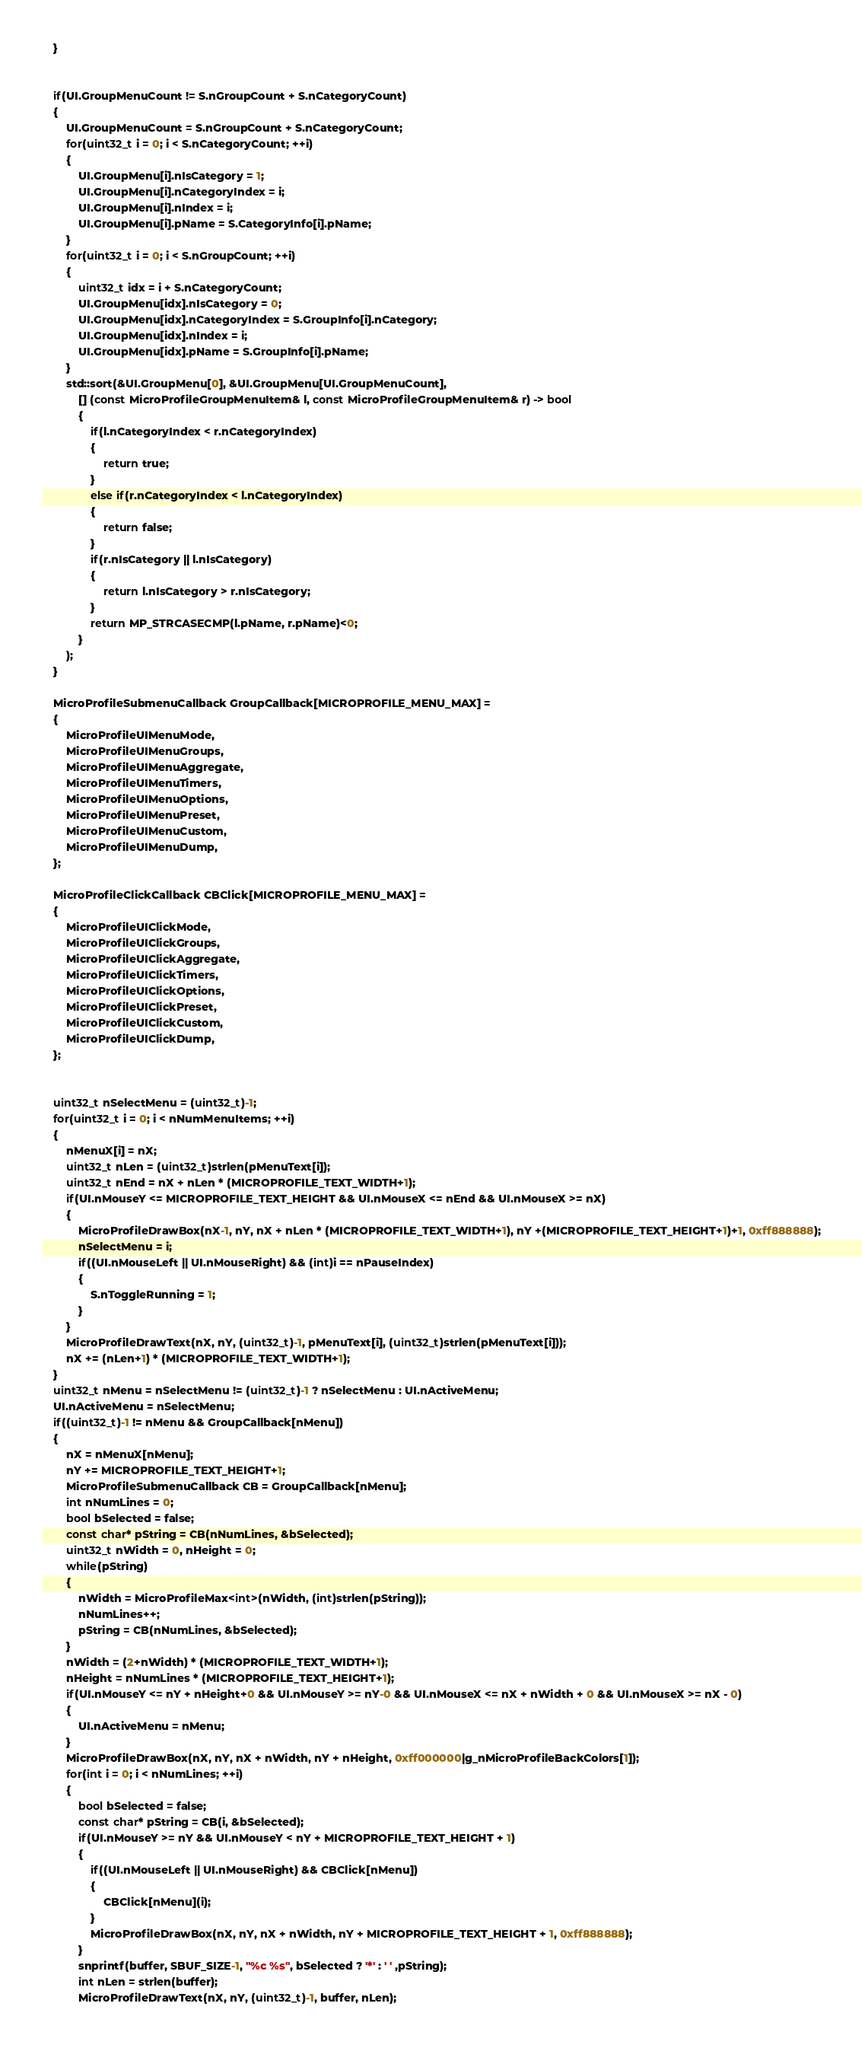Convert code to text. <code><loc_0><loc_0><loc_500><loc_500><_C_>	}


	if(UI.GroupMenuCount != S.nGroupCount + S.nCategoryCount)
	{
		UI.GroupMenuCount = S.nGroupCount + S.nCategoryCount;
		for(uint32_t i = 0; i < S.nCategoryCount; ++i)
		{
			UI.GroupMenu[i].nIsCategory = 1;
			UI.GroupMenu[i].nCategoryIndex = i;
			UI.GroupMenu[i].nIndex = i;
			UI.GroupMenu[i].pName = S.CategoryInfo[i].pName;
		}
		for(uint32_t i = 0; i < S.nGroupCount; ++i)
		{
			uint32_t idx = i + S.nCategoryCount;
			UI.GroupMenu[idx].nIsCategory = 0;
			UI.GroupMenu[idx].nCategoryIndex = S.GroupInfo[i].nCategory;
			UI.GroupMenu[idx].nIndex = i;
			UI.GroupMenu[idx].pName = S.GroupInfo[i].pName;
		}
		std::sort(&UI.GroupMenu[0], &UI.GroupMenu[UI.GroupMenuCount], 
			[] (const MicroProfileGroupMenuItem& l, const MicroProfileGroupMenuItem& r) -> bool
			{
				if(l.nCategoryIndex < r.nCategoryIndex)
				{
					return true;
				}
				else if(r.nCategoryIndex < l.nCategoryIndex)
				{
					return false;
				}
				if(r.nIsCategory || l.nIsCategory)
				{
					return l.nIsCategory > r.nIsCategory;
				}
				return MP_STRCASECMP(l.pName, r.pName)<0;
			}
		);
	}

	MicroProfileSubmenuCallback GroupCallback[MICROPROFILE_MENU_MAX] = 
	{
		MicroProfileUIMenuMode,
		MicroProfileUIMenuGroups,
		MicroProfileUIMenuAggregate,
		MicroProfileUIMenuTimers,
		MicroProfileUIMenuOptions,
		MicroProfileUIMenuPreset,
		MicroProfileUIMenuCustom,
		MicroProfileUIMenuDump,
	};

	MicroProfileClickCallback CBClick[MICROPROFILE_MENU_MAX] =
	{
		MicroProfileUIClickMode,
		MicroProfileUIClickGroups,
		MicroProfileUIClickAggregate,
		MicroProfileUIClickTimers,
		MicroProfileUIClickOptions,
		MicroProfileUIClickPreset,
		MicroProfileUIClickCustom,
		MicroProfileUIClickDump,
	};


	uint32_t nSelectMenu = (uint32_t)-1;
	for(uint32_t i = 0; i < nNumMenuItems; ++i)
	{
		nMenuX[i] = nX;
		uint32_t nLen = (uint32_t)strlen(pMenuText[i]);
		uint32_t nEnd = nX + nLen * (MICROPROFILE_TEXT_WIDTH+1);
		if(UI.nMouseY <= MICROPROFILE_TEXT_HEIGHT && UI.nMouseX <= nEnd && UI.nMouseX >= nX)
		{
			MicroProfileDrawBox(nX-1, nY, nX + nLen * (MICROPROFILE_TEXT_WIDTH+1), nY +(MICROPROFILE_TEXT_HEIGHT+1)+1, 0xff888888);
			nSelectMenu = i;
			if((UI.nMouseLeft || UI.nMouseRight) && (int)i == nPauseIndex)
			{
				S.nToggleRunning = 1;
			}
		}
		MicroProfileDrawText(nX, nY, (uint32_t)-1, pMenuText[i], (uint32_t)strlen(pMenuText[i]));
		nX += (nLen+1) * (MICROPROFILE_TEXT_WIDTH+1);
	}
	uint32_t nMenu = nSelectMenu != (uint32_t)-1 ? nSelectMenu : UI.nActiveMenu;
	UI.nActiveMenu = nSelectMenu;
	if((uint32_t)-1 != nMenu && GroupCallback[nMenu])
	{
		nX = nMenuX[nMenu];
		nY += MICROPROFILE_TEXT_HEIGHT+1;
		MicroProfileSubmenuCallback CB = GroupCallback[nMenu];
		int nNumLines = 0;
		bool bSelected = false;
		const char* pString = CB(nNumLines, &bSelected);
		uint32_t nWidth = 0, nHeight = 0;
		while(pString)
		{
			nWidth = MicroProfileMax<int>(nWidth, (int)strlen(pString));
			nNumLines++;
			pString = CB(nNumLines, &bSelected);
		}
		nWidth = (2+nWidth) * (MICROPROFILE_TEXT_WIDTH+1);
		nHeight = nNumLines * (MICROPROFILE_TEXT_HEIGHT+1);
		if(UI.nMouseY <= nY + nHeight+0 && UI.nMouseY >= nY-0 && UI.nMouseX <= nX + nWidth + 0 && UI.nMouseX >= nX - 0)
		{
			UI.nActiveMenu = nMenu;
		}
		MicroProfileDrawBox(nX, nY, nX + nWidth, nY + nHeight, 0xff000000|g_nMicroProfileBackColors[1]);
		for(int i = 0; i < nNumLines; ++i)
		{
			bool bSelected = false;
			const char* pString = CB(i, &bSelected);
			if(UI.nMouseY >= nY && UI.nMouseY < nY + MICROPROFILE_TEXT_HEIGHT + 1)
			{
				if((UI.nMouseLeft || UI.nMouseRight) && CBClick[nMenu])
				{
					CBClick[nMenu](i);
				}
				MicroProfileDrawBox(nX, nY, nX + nWidth, nY + MICROPROFILE_TEXT_HEIGHT + 1, 0xff888888);
			}
			snprintf(buffer, SBUF_SIZE-1, "%c %s", bSelected ? '*' : ' ' ,pString);
			int nLen = strlen(buffer);
			MicroProfileDrawText(nX, nY, (uint32_t)-1, buffer, nLen);</code> 